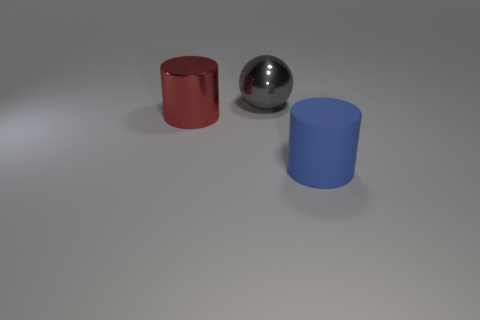There is a thing that is behind the large cylinder that is to the left of the blue rubber cylinder; what is it made of?
Keep it short and to the point. Metal. There is a big red thing that is the same shape as the blue matte object; what is its material?
Offer a very short reply. Metal. Are there any cylinders that are right of the cylinder left of the big cylinder that is to the right of the big ball?
Offer a terse response. Yes. How many other objects are the same color as the matte thing?
Offer a terse response. 0. What number of large things are behind the big red object and left of the gray thing?
Offer a very short reply. 0. What shape is the big gray object?
Your answer should be compact. Sphere. What number of other objects are there of the same material as the large gray thing?
Offer a terse response. 1. What is the color of the metallic object right of the cylinder that is to the left of the blue cylinder to the right of the red metallic cylinder?
Provide a short and direct response. Gray. There is a gray object that is the same size as the red thing; what material is it?
Your answer should be compact. Metal. How many things are either metallic objects in front of the gray object or big shiny cylinders?
Your answer should be compact. 1. 